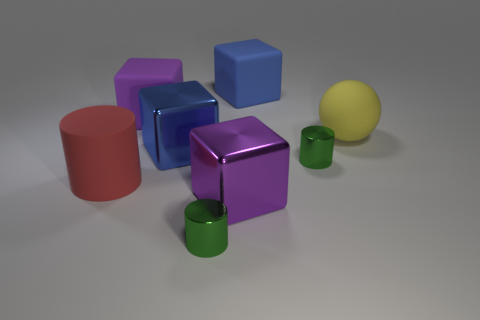Add 1 small green cylinders. How many objects exist? 9 Subtract all large red matte cylinders. How many cylinders are left? 2 Subtract all cylinders. How many objects are left? 5 Subtract 1 cubes. How many cubes are left? 3 Add 2 large yellow objects. How many large yellow objects exist? 3 Subtract all green cylinders. How many cylinders are left? 1 Subtract 1 yellow balls. How many objects are left? 7 Subtract all green cubes. Subtract all purple cylinders. How many cubes are left? 4 Subtract all purple cylinders. How many brown blocks are left? 0 Subtract all gray cylinders. Subtract all big cylinders. How many objects are left? 7 